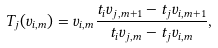<formula> <loc_0><loc_0><loc_500><loc_500>T _ { j } ( v _ { i , m } ) = v _ { i , m } \frac { t _ { i } v _ { j , m + 1 } - t _ { j } v _ { i , m + 1 } } { t _ { i } v _ { j , m } - t _ { j } v _ { i , m } } ,</formula> 